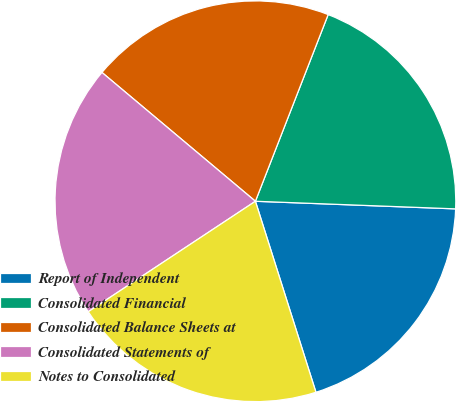Convert chart. <chart><loc_0><loc_0><loc_500><loc_500><pie_chart><fcel>Report of Independent<fcel>Consolidated Financial<fcel>Consolidated Balance Sheets at<fcel>Consolidated Statements of<fcel>Notes to Consolidated<nl><fcel>19.51%<fcel>19.69%<fcel>19.8%<fcel>20.41%<fcel>20.59%<nl></chart> 